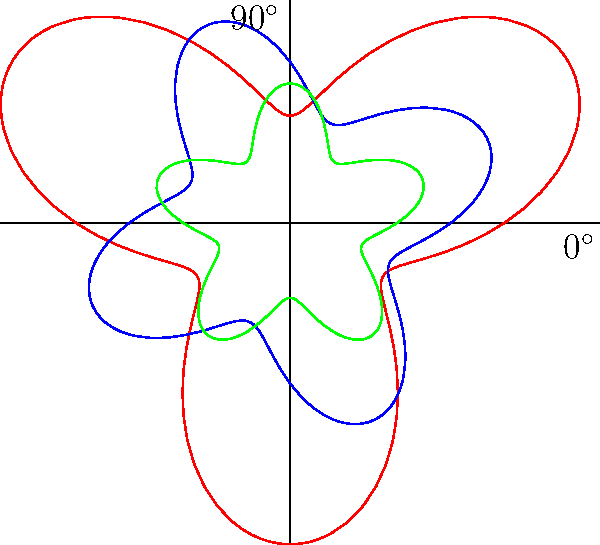Analyze the polar rose diagrams representing the directional sound emission patterns of a guitar, violin, and flute. Which instrument exhibits the most uniform sound radiation pattern, and what does this imply about its acoustic properties? To determine which instrument has the most uniform sound radiation pattern, we need to examine the shape and variation in each polar rose diagram:

1. Guitar (red curve):
   - Shows significant lobes and variations
   - Has the largest amplitude variations
   - Indicates strong directional sound emission

2. Violin (blue curve):
   - Shows moderate lobes and variations
   - Has intermediate amplitude variations
   - Indicates some directional sound emission

3. Flute (green curve):
   - Shows the least variation in its pattern
   - Has the smallest amplitude variations
   - Closest to a circular shape

The flute exhibits the most uniform sound radiation pattern because its polar rose diagram is closest to a perfect circle. This implies:

1. More consistent sound projection in all directions
2. Less variation in timbre and volume depending on listener position
3. Better sound dispersion in performance spaces
4. Potentially easier to record or amplify due to more predictable sound emission

The uniformity in the flute's sound radiation is likely due to its cylindrical shape and the way sound is produced through the air column, resulting in more omnidirectional sound emission compared to the string instruments.
Answer: Flute; most omnidirectional sound emission 